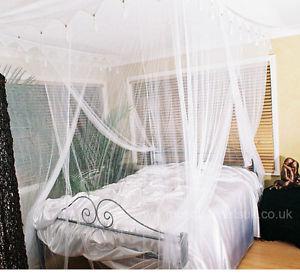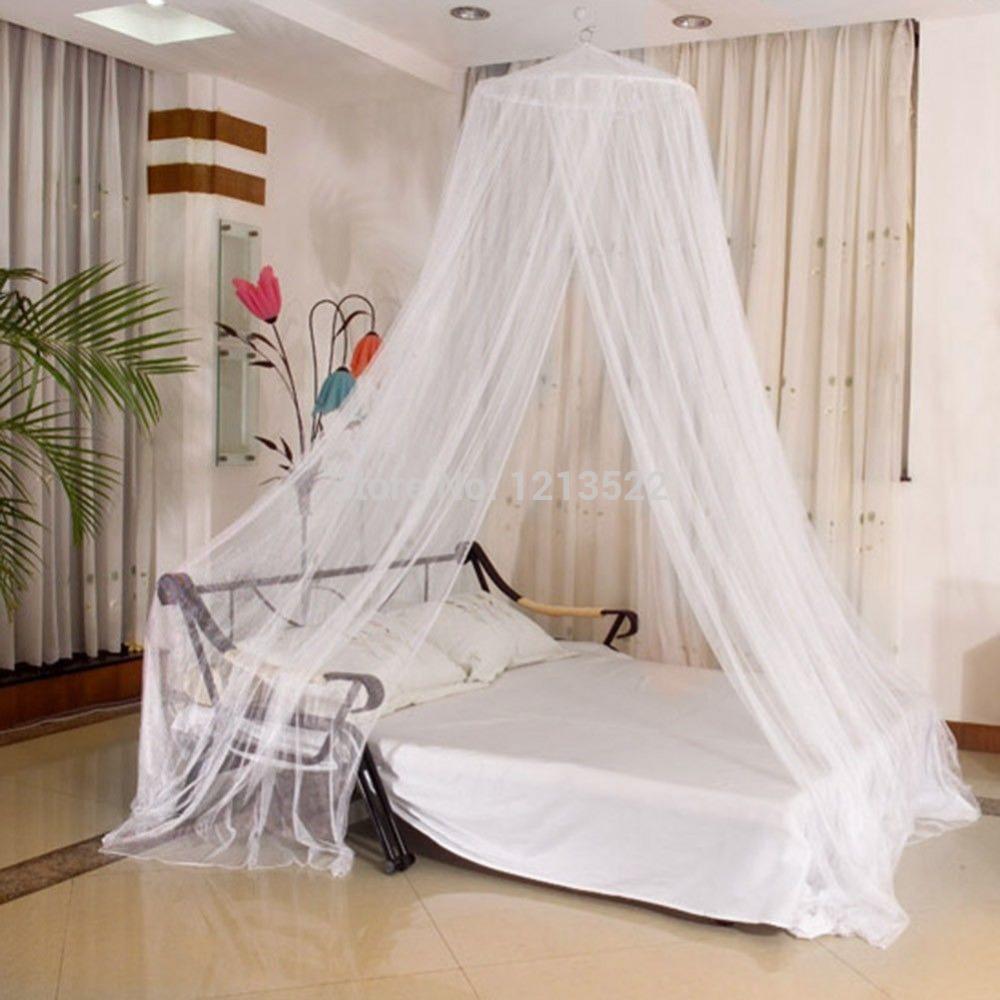The first image is the image on the left, the second image is the image on the right. Examine the images to the left and right. Is the description "In one image, gauzy bed curtains are draped from a square frame, and knotted halfway down at each corner." accurate? Answer yes or no. No. 